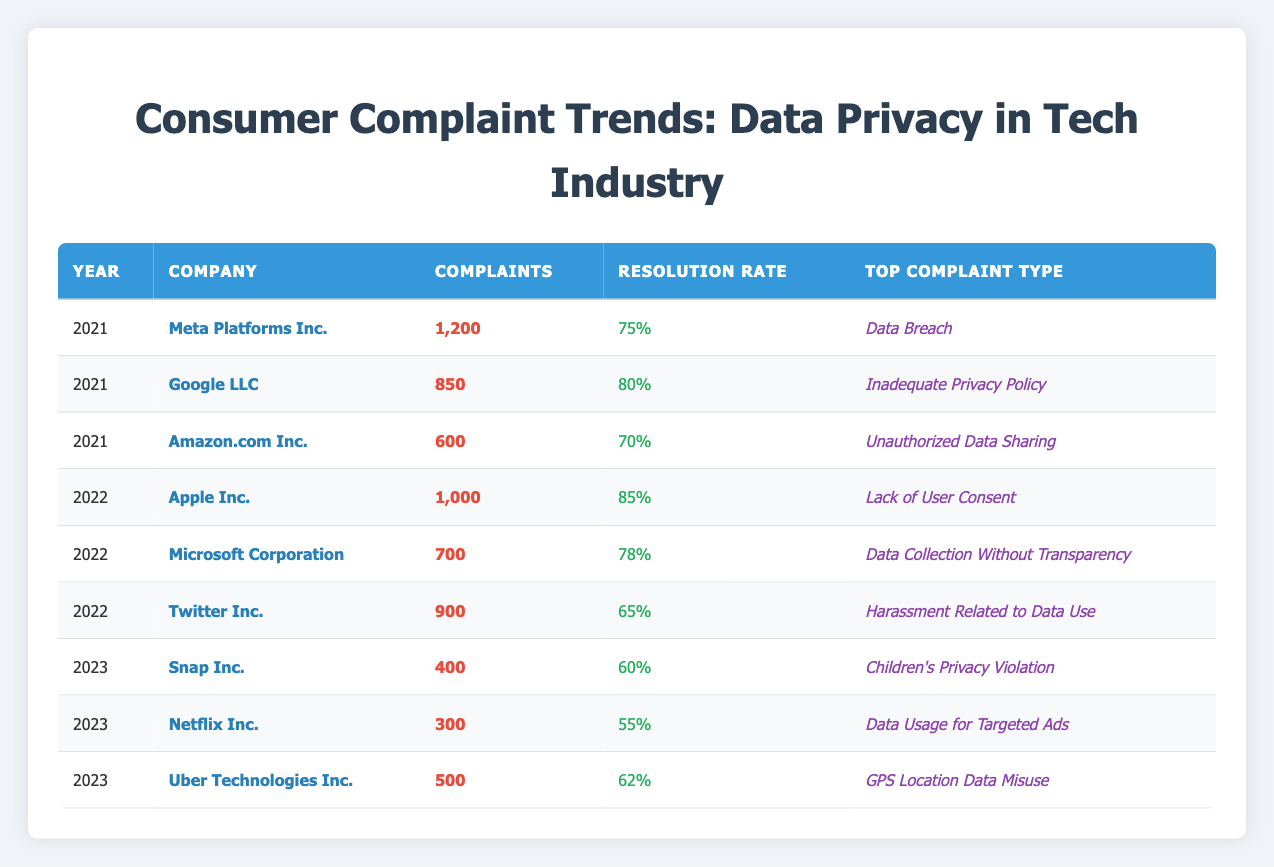What was the highest number of complaints received in a single year? The highest number of complaints can be found in the table by comparing the "Complaints Received" column. In 2021, Meta Platforms Inc. had 1,200 complaints, while other companies had fewer complaints in the same year or subsequent years.
Answer: 1200 What is the resolution rate for Google LLC in 2021? The resolution rate for Google LLC is listed directly in the table under the "Resolution Rate" column for the year 2021, which is 80%.
Answer: 80% Which company's top complaint type changed from 2021 to 2022? By examining the rows for each company from 2021 to 2022, Amazon.com Inc. had "Unauthorized Data Sharing" as the top complaint type in 2021, which changed to "Data Collection Without Transparency" for Microsoft Corporation in 2022. So, the company with the change is Amazon.com Inc.
Answer: Amazon.com Inc How many total complaints were received by all companies in 2023? To find the total complaints for 2023, we need to add the complaints from Snap Inc. (400), Netflix Inc. (300), and Uber Technologies Inc. (500): 400 + 300 + 500 = 1200.
Answer: 1200 Did Apple Inc. have a higher resolution rate than Meta Platforms Inc. in 2022? Apple's resolution rate in 2022 is 85%, while Meta Platforms Inc. had a resolution rate of 75% in 2021. Since 85% is greater than 75%, the answer is yes.
Answer: Yes What is the average resolution rate from companies in the year 2021? We calculate the average resolution rate for 2021 as follows: (75 + 80 + 70) / 3, = 225 / 3 = 75%. We sum the rates for Meta Platforms Inc., Google LLC, and Amazon.com Inc. Divide by the number of companies to find the average.
Answer: 75 Which company had the lowest resolution rate in 2022? Looking at the "Resolution Rate" column for 2022, the lowest resolution rate was for Twitter Inc., which was 65%.
Answer: 65 What was the top complaint type for Netflix Inc. in 2023? The top complaint type for Netflix Inc. in 2023 is listed in the table as "Data Usage for Targeted Ads."
Answer: Data Usage for Targeted Ads 